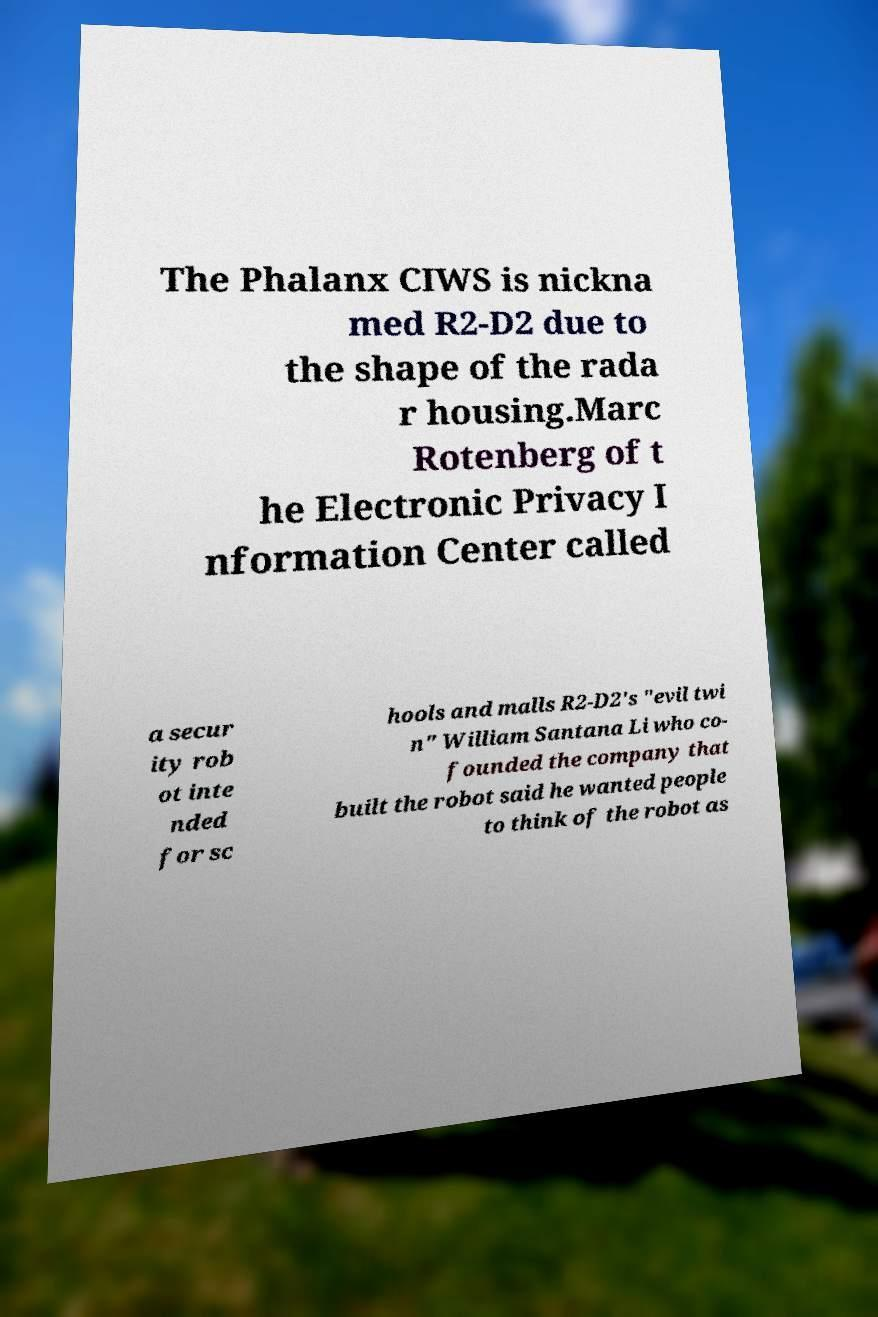Could you assist in decoding the text presented in this image and type it out clearly? The Phalanx CIWS is nickna med R2-D2 due to the shape of the rada r housing.Marc Rotenberg of t he Electronic Privacy I nformation Center called a secur ity rob ot inte nded for sc hools and malls R2-D2's "evil twi n" William Santana Li who co- founded the company that built the robot said he wanted people to think of the robot as 